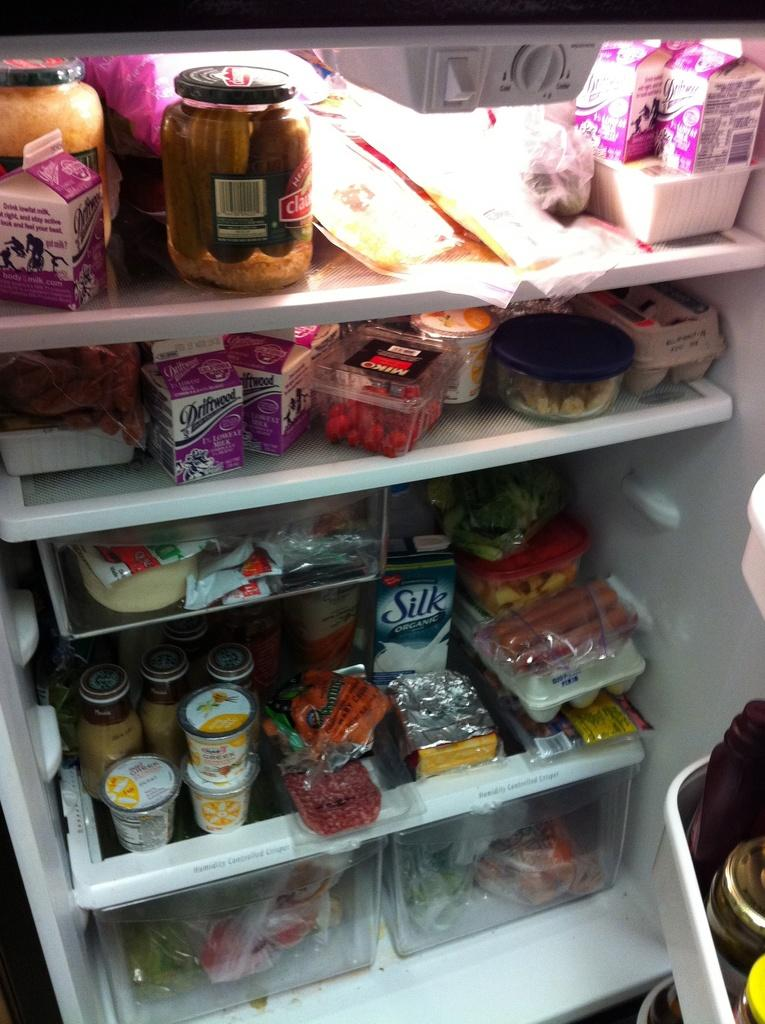<image>
Present a compact description of the photo's key features. Among various items in a refrigerator is a container of Silk Organic milk. 